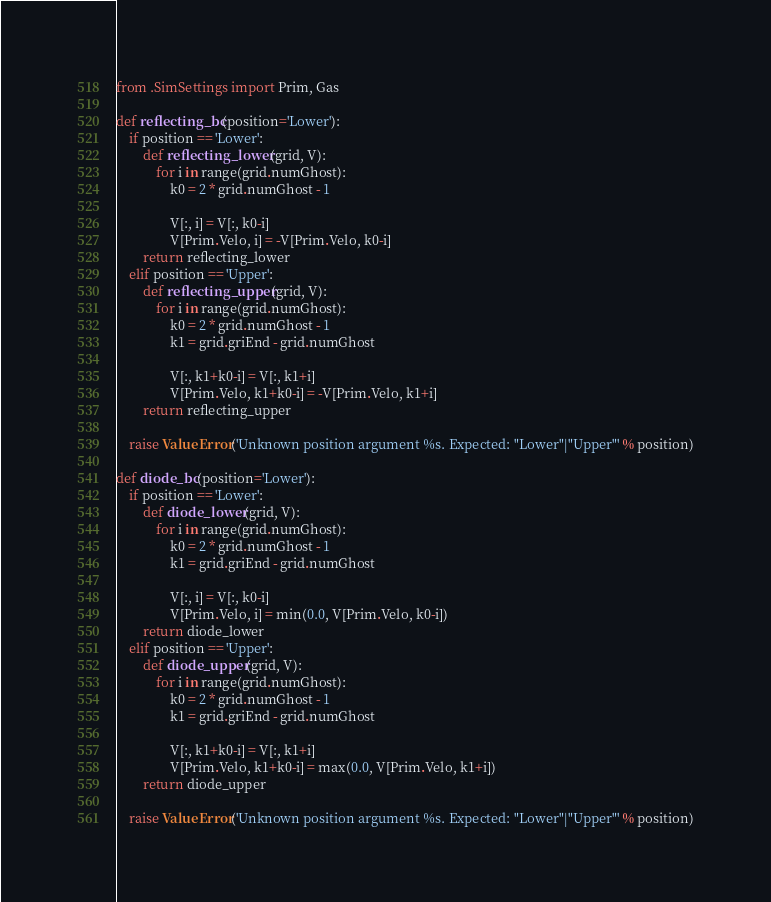<code> <loc_0><loc_0><loc_500><loc_500><_Python_>from .SimSettings import Prim, Gas

def reflecting_bc(position='Lower'):
    if position == 'Lower':
        def reflecting_lower(grid, V):
            for i in range(grid.numGhost):
                k0 = 2 * grid.numGhost - 1

                V[:, i] = V[:, k0-i]
                V[Prim.Velo, i] = -V[Prim.Velo, k0-i]
        return reflecting_lower
    elif position == 'Upper':
        def reflecting_upper(grid, V):
            for i in range(grid.numGhost):
                k0 = 2 * grid.numGhost - 1
                k1 = grid.griEnd - grid.numGhost

                V[:, k1+k0-i] = V[:, k1+i]
                V[Prim.Velo, k1+k0-i] = -V[Prim.Velo, k1+i]
        return reflecting_upper
    
    raise ValueError('Unknown position argument %s. Expected: "Lower"|"Upper"' % position)

def diode_bc(position='Lower'):
    if position == 'Lower':
        def diode_lower(grid, V):
            for i in range(grid.numGhost):
                k0 = 2 * grid.numGhost - 1
                k1 = grid.griEnd - grid.numGhost

                V[:, i] = V[:, k0-i]
                V[Prim.Velo, i] = min(0.0, V[Prim.Velo, k0-i])
        return diode_lower
    elif position == 'Upper':
        def diode_upper(grid, V):
            for i in range(grid.numGhost):
                k0 = 2 * grid.numGhost - 1
                k1 = grid.griEnd - grid.numGhost

                V[:, k1+k0-i] = V[:, k1+i]
                V[Prim.Velo, k1+k0-i] = max(0.0, V[Prim.Velo, k1+i])
        return diode_upper
    
    raise ValueError('Unknown position argument %s. Expected: "Lower"|"Upper"' % position)
</code> 